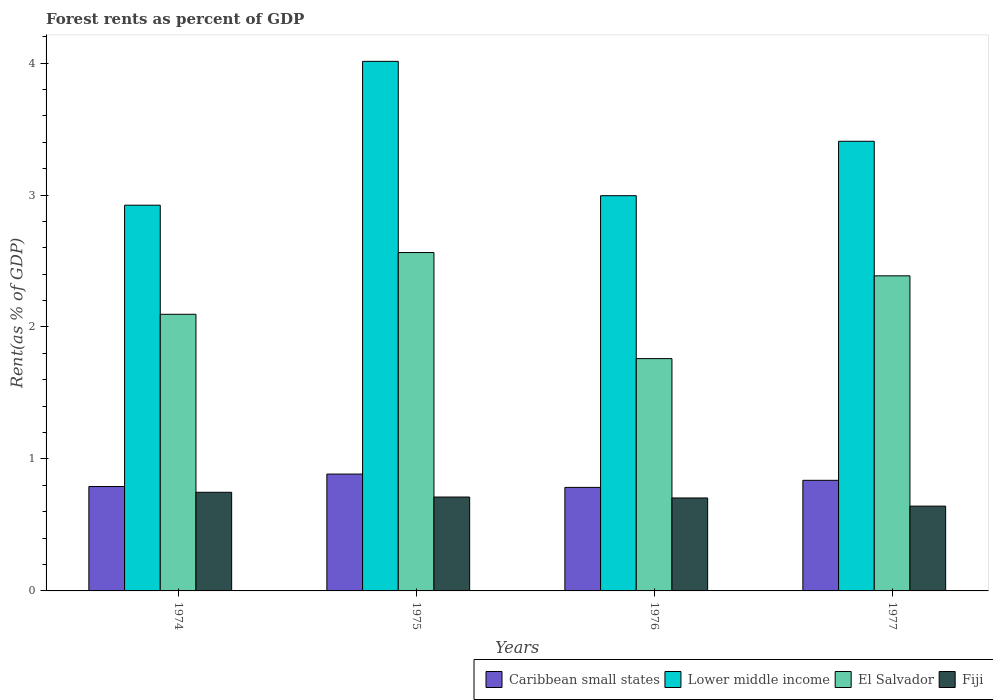How many bars are there on the 4th tick from the right?
Your response must be concise. 4. What is the label of the 2nd group of bars from the left?
Make the answer very short. 1975. In how many cases, is the number of bars for a given year not equal to the number of legend labels?
Offer a very short reply. 0. What is the forest rent in Fiji in 1975?
Offer a terse response. 0.71. Across all years, what is the maximum forest rent in Fiji?
Make the answer very short. 0.75. Across all years, what is the minimum forest rent in Caribbean small states?
Ensure brevity in your answer.  0.78. In which year was the forest rent in El Salvador maximum?
Offer a terse response. 1975. In which year was the forest rent in Caribbean small states minimum?
Keep it short and to the point. 1976. What is the total forest rent in El Salvador in the graph?
Your answer should be compact. 8.81. What is the difference between the forest rent in Fiji in 1974 and that in 1975?
Make the answer very short. 0.04. What is the difference between the forest rent in Lower middle income in 1977 and the forest rent in Fiji in 1974?
Ensure brevity in your answer.  2.66. What is the average forest rent in El Salvador per year?
Your response must be concise. 2.2. In the year 1975, what is the difference between the forest rent in Caribbean small states and forest rent in El Salvador?
Ensure brevity in your answer.  -1.68. What is the ratio of the forest rent in Caribbean small states in 1975 to that in 1977?
Provide a succinct answer. 1.06. Is the difference between the forest rent in Caribbean small states in 1974 and 1975 greater than the difference between the forest rent in El Salvador in 1974 and 1975?
Make the answer very short. Yes. What is the difference between the highest and the second highest forest rent in Lower middle income?
Offer a terse response. 0.61. What is the difference between the highest and the lowest forest rent in El Salvador?
Offer a terse response. 0.8. In how many years, is the forest rent in El Salvador greater than the average forest rent in El Salvador taken over all years?
Give a very brief answer. 2. Is the sum of the forest rent in Caribbean small states in 1974 and 1975 greater than the maximum forest rent in Lower middle income across all years?
Your answer should be very brief. No. What does the 4th bar from the left in 1974 represents?
Offer a very short reply. Fiji. What does the 4th bar from the right in 1975 represents?
Provide a short and direct response. Caribbean small states. How many bars are there?
Make the answer very short. 16. What is the difference between two consecutive major ticks on the Y-axis?
Your answer should be very brief. 1. Are the values on the major ticks of Y-axis written in scientific E-notation?
Make the answer very short. No. Where does the legend appear in the graph?
Ensure brevity in your answer.  Bottom right. How many legend labels are there?
Your answer should be compact. 4. What is the title of the graph?
Make the answer very short. Forest rents as percent of GDP. Does "Bahrain" appear as one of the legend labels in the graph?
Give a very brief answer. No. What is the label or title of the X-axis?
Your response must be concise. Years. What is the label or title of the Y-axis?
Your answer should be compact. Rent(as % of GDP). What is the Rent(as % of GDP) of Caribbean small states in 1974?
Provide a succinct answer. 0.79. What is the Rent(as % of GDP) in Lower middle income in 1974?
Offer a terse response. 2.92. What is the Rent(as % of GDP) of El Salvador in 1974?
Ensure brevity in your answer.  2.1. What is the Rent(as % of GDP) in Fiji in 1974?
Ensure brevity in your answer.  0.75. What is the Rent(as % of GDP) of Caribbean small states in 1975?
Offer a terse response. 0.89. What is the Rent(as % of GDP) of Lower middle income in 1975?
Provide a succinct answer. 4.01. What is the Rent(as % of GDP) of El Salvador in 1975?
Provide a short and direct response. 2.56. What is the Rent(as % of GDP) in Fiji in 1975?
Your response must be concise. 0.71. What is the Rent(as % of GDP) of Caribbean small states in 1976?
Offer a terse response. 0.78. What is the Rent(as % of GDP) in Lower middle income in 1976?
Provide a succinct answer. 2.99. What is the Rent(as % of GDP) in El Salvador in 1976?
Your answer should be compact. 1.76. What is the Rent(as % of GDP) in Fiji in 1976?
Keep it short and to the point. 0.7. What is the Rent(as % of GDP) in Caribbean small states in 1977?
Provide a succinct answer. 0.84. What is the Rent(as % of GDP) in Lower middle income in 1977?
Your response must be concise. 3.41. What is the Rent(as % of GDP) in El Salvador in 1977?
Provide a short and direct response. 2.39. What is the Rent(as % of GDP) of Fiji in 1977?
Make the answer very short. 0.64. Across all years, what is the maximum Rent(as % of GDP) in Caribbean small states?
Provide a succinct answer. 0.89. Across all years, what is the maximum Rent(as % of GDP) in Lower middle income?
Give a very brief answer. 4.01. Across all years, what is the maximum Rent(as % of GDP) in El Salvador?
Provide a short and direct response. 2.56. Across all years, what is the maximum Rent(as % of GDP) in Fiji?
Provide a succinct answer. 0.75. Across all years, what is the minimum Rent(as % of GDP) in Caribbean small states?
Provide a succinct answer. 0.78. Across all years, what is the minimum Rent(as % of GDP) in Lower middle income?
Give a very brief answer. 2.92. Across all years, what is the minimum Rent(as % of GDP) of El Salvador?
Provide a succinct answer. 1.76. Across all years, what is the minimum Rent(as % of GDP) of Fiji?
Your answer should be very brief. 0.64. What is the total Rent(as % of GDP) in Caribbean small states in the graph?
Your answer should be very brief. 3.3. What is the total Rent(as % of GDP) of Lower middle income in the graph?
Offer a very short reply. 13.34. What is the total Rent(as % of GDP) in El Salvador in the graph?
Your response must be concise. 8.81. What is the total Rent(as % of GDP) in Fiji in the graph?
Give a very brief answer. 2.81. What is the difference between the Rent(as % of GDP) of Caribbean small states in 1974 and that in 1975?
Provide a succinct answer. -0.09. What is the difference between the Rent(as % of GDP) in Lower middle income in 1974 and that in 1975?
Your response must be concise. -1.09. What is the difference between the Rent(as % of GDP) in El Salvador in 1974 and that in 1975?
Your answer should be very brief. -0.47. What is the difference between the Rent(as % of GDP) in Fiji in 1974 and that in 1975?
Keep it short and to the point. 0.04. What is the difference between the Rent(as % of GDP) of Caribbean small states in 1974 and that in 1976?
Provide a succinct answer. 0.01. What is the difference between the Rent(as % of GDP) in Lower middle income in 1974 and that in 1976?
Your answer should be very brief. -0.07. What is the difference between the Rent(as % of GDP) of El Salvador in 1974 and that in 1976?
Your answer should be compact. 0.34. What is the difference between the Rent(as % of GDP) in Fiji in 1974 and that in 1976?
Keep it short and to the point. 0.04. What is the difference between the Rent(as % of GDP) of Caribbean small states in 1974 and that in 1977?
Make the answer very short. -0.05. What is the difference between the Rent(as % of GDP) of Lower middle income in 1974 and that in 1977?
Your answer should be very brief. -0.48. What is the difference between the Rent(as % of GDP) in El Salvador in 1974 and that in 1977?
Offer a terse response. -0.29. What is the difference between the Rent(as % of GDP) in Fiji in 1974 and that in 1977?
Your answer should be very brief. 0.1. What is the difference between the Rent(as % of GDP) in Caribbean small states in 1975 and that in 1976?
Your answer should be compact. 0.1. What is the difference between the Rent(as % of GDP) in El Salvador in 1975 and that in 1976?
Offer a terse response. 0.8. What is the difference between the Rent(as % of GDP) of Fiji in 1975 and that in 1976?
Keep it short and to the point. 0.01. What is the difference between the Rent(as % of GDP) in Caribbean small states in 1975 and that in 1977?
Your answer should be compact. 0.05. What is the difference between the Rent(as % of GDP) in Lower middle income in 1975 and that in 1977?
Your response must be concise. 0.61. What is the difference between the Rent(as % of GDP) of El Salvador in 1975 and that in 1977?
Keep it short and to the point. 0.18. What is the difference between the Rent(as % of GDP) of Fiji in 1975 and that in 1977?
Your response must be concise. 0.07. What is the difference between the Rent(as % of GDP) of Caribbean small states in 1976 and that in 1977?
Your answer should be compact. -0.05. What is the difference between the Rent(as % of GDP) of Lower middle income in 1976 and that in 1977?
Make the answer very short. -0.41. What is the difference between the Rent(as % of GDP) of El Salvador in 1976 and that in 1977?
Give a very brief answer. -0.63. What is the difference between the Rent(as % of GDP) in Fiji in 1976 and that in 1977?
Give a very brief answer. 0.06. What is the difference between the Rent(as % of GDP) in Caribbean small states in 1974 and the Rent(as % of GDP) in Lower middle income in 1975?
Keep it short and to the point. -3.22. What is the difference between the Rent(as % of GDP) in Caribbean small states in 1974 and the Rent(as % of GDP) in El Salvador in 1975?
Make the answer very short. -1.77. What is the difference between the Rent(as % of GDP) of Caribbean small states in 1974 and the Rent(as % of GDP) of Fiji in 1975?
Offer a very short reply. 0.08. What is the difference between the Rent(as % of GDP) in Lower middle income in 1974 and the Rent(as % of GDP) in El Salvador in 1975?
Keep it short and to the point. 0.36. What is the difference between the Rent(as % of GDP) in Lower middle income in 1974 and the Rent(as % of GDP) in Fiji in 1975?
Make the answer very short. 2.21. What is the difference between the Rent(as % of GDP) of El Salvador in 1974 and the Rent(as % of GDP) of Fiji in 1975?
Make the answer very short. 1.38. What is the difference between the Rent(as % of GDP) in Caribbean small states in 1974 and the Rent(as % of GDP) in Lower middle income in 1976?
Offer a terse response. -2.2. What is the difference between the Rent(as % of GDP) of Caribbean small states in 1974 and the Rent(as % of GDP) of El Salvador in 1976?
Make the answer very short. -0.97. What is the difference between the Rent(as % of GDP) in Caribbean small states in 1974 and the Rent(as % of GDP) in Fiji in 1976?
Give a very brief answer. 0.09. What is the difference between the Rent(as % of GDP) of Lower middle income in 1974 and the Rent(as % of GDP) of El Salvador in 1976?
Provide a succinct answer. 1.16. What is the difference between the Rent(as % of GDP) in Lower middle income in 1974 and the Rent(as % of GDP) in Fiji in 1976?
Your answer should be very brief. 2.22. What is the difference between the Rent(as % of GDP) in El Salvador in 1974 and the Rent(as % of GDP) in Fiji in 1976?
Provide a short and direct response. 1.39. What is the difference between the Rent(as % of GDP) of Caribbean small states in 1974 and the Rent(as % of GDP) of Lower middle income in 1977?
Provide a short and direct response. -2.62. What is the difference between the Rent(as % of GDP) of Caribbean small states in 1974 and the Rent(as % of GDP) of El Salvador in 1977?
Keep it short and to the point. -1.6. What is the difference between the Rent(as % of GDP) in Caribbean small states in 1974 and the Rent(as % of GDP) in Fiji in 1977?
Offer a very short reply. 0.15. What is the difference between the Rent(as % of GDP) of Lower middle income in 1974 and the Rent(as % of GDP) of El Salvador in 1977?
Ensure brevity in your answer.  0.54. What is the difference between the Rent(as % of GDP) of Lower middle income in 1974 and the Rent(as % of GDP) of Fiji in 1977?
Offer a terse response. 2.28. What is the difference between the Rent(as % of GDP) of El Salvador in 1974 and the Rent(as % of GDP) of Fiji in 1977?
Provide a short and direct response. 1.45. What is the difference between the Rent(as % of GDP) of Caribbean small states in 1975 and the Rent(as % of GDP) of Lower middle income in 1976?
Keep it short and to the point. -2.11. What is the difference between the Rent(as % of GDP) in Caribbean small states in 1975 and the Rent(as % of GDP) in El Salvador in 1976?
Provide a succinct answer. -0.87. What is the difference between the Rent(as % of GDP) in Caribbean small states in 1975 and the Rent(as % of GDP) in Fiji in 1976?
Give a very brief answer. 0.18. What is the difference between the Rent(as % of GDP) of Lower middle income in 1975 and the Rent(as % of GDP) of El Salvador in 1976?
Keep it short and to the point. 2.25. What is the difference between the Rent(as % of GDP) of Lower middle income in 1975 and the Rent(as % of GDP) of Fiji in 1976?
Ensure brevity in your answer.  3.31. What is the difference between the Rent(as % of GDP) in El Salvador in 1975 and the Rent(as % of GDP) in Fiji in 1976?
Your response must be concise. 1.86. What is the difference between the Rent(as % of GDP) of Caribbean small states in 1975 and the Rent(as % of GDP) of Lower middle income in 1977?
Offer a terse response. -2.52. What is the difference between the Rent(as % of GDP) in Caribbean small states in 1975 and the Rent(as % of GDP) in El Salvador in 1977?
Make the answer very short. -1.5. What is the difference between the Rent(as % of GDP) in Caribbean small states in 1975 and the Rent(as % of GDP) in Fiji in 1977?
Offer a very short reply. 0.24. What is the difference between the Rent(as % of GDP) of Lower middle income in 1975 and the Rent(as % of GDP) of El Salvador in 1977?
Your answer should be compact. 1.63. What is the difference between the Rent(as % of GDP) in Lower middle income in 1975 and the Rent(as % of GDP) in Fiji in 1977?
Provide a succinct answer. 3.37. What is the difference between the Rent(as % of GDP) of El Salvador in 1975 and the Rent(as % of GDP) of Fiji in 1977?
Give a very brief answer. 1.92. What is the difference between the Rent(as % of GDP) in Caribbean small states in 1976 and the Rent(as % of GDP) in Lower middle income in 1977?
Offer a very short reply. -2.62. What is the difference between the Rent(as % of GDP) in Caribbean small states in 1976 and the Rent(as % of GDP) in El Salvador in 1977?
Offer a very short reply. -1.6. What is the difference between the Rent(as % of GDP) in Caribbean small states in 1976 and the Rent(as % of GDP) in Fiji in 1977?
Provide a succinct answer. 0.14. What is the difference between the Rent(as % of GDP) of Lower middle income in 1976 and the Rent(as % of GDP) of El Salvador in 1977?
Your answer should be compact. 0.61. What is the difference between the Rent(as % of GDP) in Lower middle income in 1976 and the Rent(as % of GDP) in Fiji in 1977?
Your answer should be very brief. 2.35. What is the difference between the Rent(as % of GDP) of El Salvador in 1976 and the Rent(as % of GDP) of Fiji in 1977?
Keep it short and to the point. 1.12. What is the average Rent(as % of GDP) in Caribbean small states per year?
Offer a very short reply. 0.82. What is the average Rent(as % of GDP) in Lower middle income per year?
Give a very brief answer. 3.33. What is the average Rent(as % of GDP) in El Salvador per year?
Provide a succinct answer. 2.2. What is the average Rent(as % of GDP) in Fiji per year?
Provide a short and direct response. 0.7. In the year 1974, what is the difference between the Rent(as % of GDP) of Caribbean small states and Rent(as % of GDP) of Lower middle income?
Your answer should be very brief. -2.13. In the year 1974, what is the difference between the Rent(as % of GDP) of Caribbean small states and Rent(as % of GDP) of El Salvador?
Offer a terse response. -1.31. In the year 1974, what is the difference between the Rent(as % of GDP) of Caribbean small states and Rent(as % of GDP) of Fiji?
Offer a very short reply. 0.04. In the year 1974, what is the difference between the Rent(as % of GDP) of Lower middle income and Rent(as % of GDP) of El Salvador?
Provide a short and direct response. 0.83. In the year 1974, what is the difference between the Rent(as % of GDP) of Lower middle income and Rent(as % of GDP) of Fiji?
Ensure brevity in your answer.  2.18. In the year 1974, what is the difference between the Rent(as % of GDP) in El Salvador and Rent(as % of GDP) in Fiji?
Offer a very short reply. 1.35. In the year 1975, what is the difference between the Rent(as % of GDP) of Caribbean small states and Rent(as % of GDP) of Lower middle income?
Provide a short and direct response. -3.13. In the year 1975, what is the difference between the Rent(as % of GDP) in Caribbean small states and Rent(as % of GDP) in El Salvador?
Your response must be concise. -1.68. In the year 1975, what is the difference between the Rent(as % of GDP) in Caribbean small states and Rent(as % of GDP) in Fiji?
Give a very brief answer. 0.17. In the year 1975, what is the difference between the Rent(as % of GDP) in Lower middle income and Rent(as % of GDP) in El Salvador?
Offer a very short reply. 1.45. In the year 1975, what is the difference between the Rent(as % of GDP) of Lower middle income and Rent(as % of GDP) of Fiji?
Give a very brief answer. 3.3. In the year 1975, what is the difference between the Rent(as % of GDP) in El Salvador and Rent(as % of GDP) in Fiji?
Make the answer very short. 1.85. In the year 1976, what is the difference between the Rent(as % of GDP) in Caribbean small states and Rent(as % of GDP) in Lower middle income?
Your answer should be very brief. -2.21. In the year 1976, what is the difference between the Rent(as % of GDP) in Caribbean small states and Rent(as % of GDP) in El Salvador?
Your answer should be very brief. -0.98. In the year 1976, what is the difference between the Rent(as % of GDP) of Caribbean small states and Rent(as % of GDP) of Fiji?
Your response must be concise. 0.08. In the year 1976, what is the difference between the Rent(as % of GDP) of Lower middle income and Rent(as % of GDP) of El Salvador?
Keep it short and to the point. 1.23. In the year 1976, what is the difference between the Rent(as % of GDP) of Lower middle income and Rent(as % of GDP) of Fiji?
Your answer should be very brief. 2.29. In the year 1976, what is the difference between the Rent(as % of GDP) of El Salvador and Rent(as % of GDP) of Fiji?
Offer a very short reply. 1.06. In the year 1977, what is the difference between the Rent(as % of GDP) in Caribbean small states and Rent(as % of GDP) in Lower middle income?
Ensure brevity in your answer.  -2.57. In the year 1977, what is the difference between the Rent(as % of GDP) in Caribbean small states and Rent(as % of GDP) in El Salvador?
Offer a terse response. -1.55. In the year 1977, what is the difference between the Rent(as % of GDP) in Caribbean small states and Rent(as % of GDP) in Fiji?
Offer a terse response. 0.2. In the year 1977, what is the difference between the Rent(as % of GDP) in Lower middle income and Rent(as % of GDP) in El Salvador?
Give a very brief answer. 1.02. In the year 1977, what is the difference between the Rent(as % of GDP) in Lower middle income and Rent(as % of GDP) in Fiji?
Make the answer very short. 2.76. In the year 1977, what is the difference between the Rent(as % of GDP) in El Salvador and Rent(as % of GDP) in Fiji?
Your response must be concise. 1.75. What is the ratio of the Rent(as % of GDP) in Caribbean small states in 1974 to that in 1975?
Give a very brief answer. 0.89. What is the ratio of the Rent(as % of GDP) in Lower middle income in 1974 to that in 1975?
Provide a succinct answer. 0.73. What is the ratio of the Rent(as % of GDP) in El Salvador in 1974 to that in 1975?
Offer a very short reply. 0.82. What is the ratio of the Rent(as % of GDP) in Fiji in 1974 to that in 1975?
Provide a short and direct response. 1.05. What is the ratio of the Rent(as % of GDP) of Caribbean small states in 1974 to that in 1976?
Offer a very short reply. 1.01. What is the ratio of the Rent(as % of GDP) in Lower middle income in 1974 to that in 1976?
Your answer should be very brief. 0.98. What is the ratio of the Rent(as % of GDP) of El Salvador in 1974 to that in 1976?
Make the answer very short. 1.19. What is the ratio of the Rent(as % of GDP) in Fiji in 1974 to that in 1976?
Offer a terse response. 1.06. What is the ratio of the Rent(as % of GDP) of Caribbean small states in 1974 to that in 1977?
Your response must be concise. 0.94. What is the ratio of the Rent(as % of GDP) in Lower middle income in 1974 to that in 1977?
Offer a terse response. 0.86. What is the ratio of the Rent(as % of GDP) in El Salvador in 1974 to that in 1977?
Keep it short and to the point. 0.88. What is the ratio of the Rent(as % of GDP) in Fiji in 1974 to that in 1977?
Your response must be concise. 1.16. What is the ratio of the Rent(as % of GDP) of Caribbean small states in 1975 to that in 1976?
Give a very brief answer. 1.13. What is the ratio of the Rent(as % of GDP) of Lower middle income in 1975 to that in 1976?
Give a very brief answer. 1.34. What is the ratio of the Rent(as % of GDP) of El Salvador in 1975 to that in 1976?
Make the answer very short. 1.46. What is the ratio of the Rent(as % of GDP) of Fiji in 1975 to that in 1976?
Your answer should be very brief. 1.01. What is the ratio of the Rent(as % of GDP) of Caribbean small states in 1975 to that in 1977?
Your response must be concise. 1.06. What is the ratio of the Rent(as % of GDP) in Lower middle income in 1975 to that in 1977?
Give a very brief answer. 1.18. What is the ratio of the Rent(as % of GDP) in El Salvador in 1975 to that in 1977?
Keep it short and to the point. 1.07. What is the ratio of the Rent(as % of GDP) of Fiji in 1975 to that in 1977?
Your response must be concise. 1.11. What is the ratio of the Rent(as % of GDP) of Caribbean small states in 1976 to that in 1977?
Offer a terse response. 0.94. What is the ratio of the Rent(as % of GDP) of Lower middle income in 1976 to that in 1977?
Offer a terse response. 0.88. What is the ratio of the Rent(as % of GDP) of El Salvador in 1976 to that in 1977?
Provide a short and direct response. 0.74. What is the ratio of the Rent(as % of GDP) of Fiji in 1976 to that in 1977?
Your answer should be very brief. 1.1. What is the difference between the highest and the second highest Rent(as % of GDP) of Caribbean small states?
Offer a terse response. 0.05. What is the difference between the highest and the second highest Rent(as % of GDP) of Lower middle income?
Offer a terse response. 0.61. What is the difference between the highest and the second highest Rent(as % of GDP) in El Salvador?
Offer a very short reply. 0.18. What is the difference between the highest and the second highest Rent(as % of GDP) in Fiji?
Offer a terse response. 0.04. What is the difference between the highest and the lowest Rent(as % of GDP) of Caribbean small states?
Offer a terse response. 0.1. What is the difference between the highest and the lowest Rent(as % of GDP) in Lower middle income?
Keep it short and to the point. 1.09. What is the difference between the highest and the lowest Rent(as % of GDP) in El Salvador?
Make the answer very short. 0.8. What is the difference between the highest and the lowest Rent(as % of GDP) in Fiji?
Give a very brief answer. 0.1. 